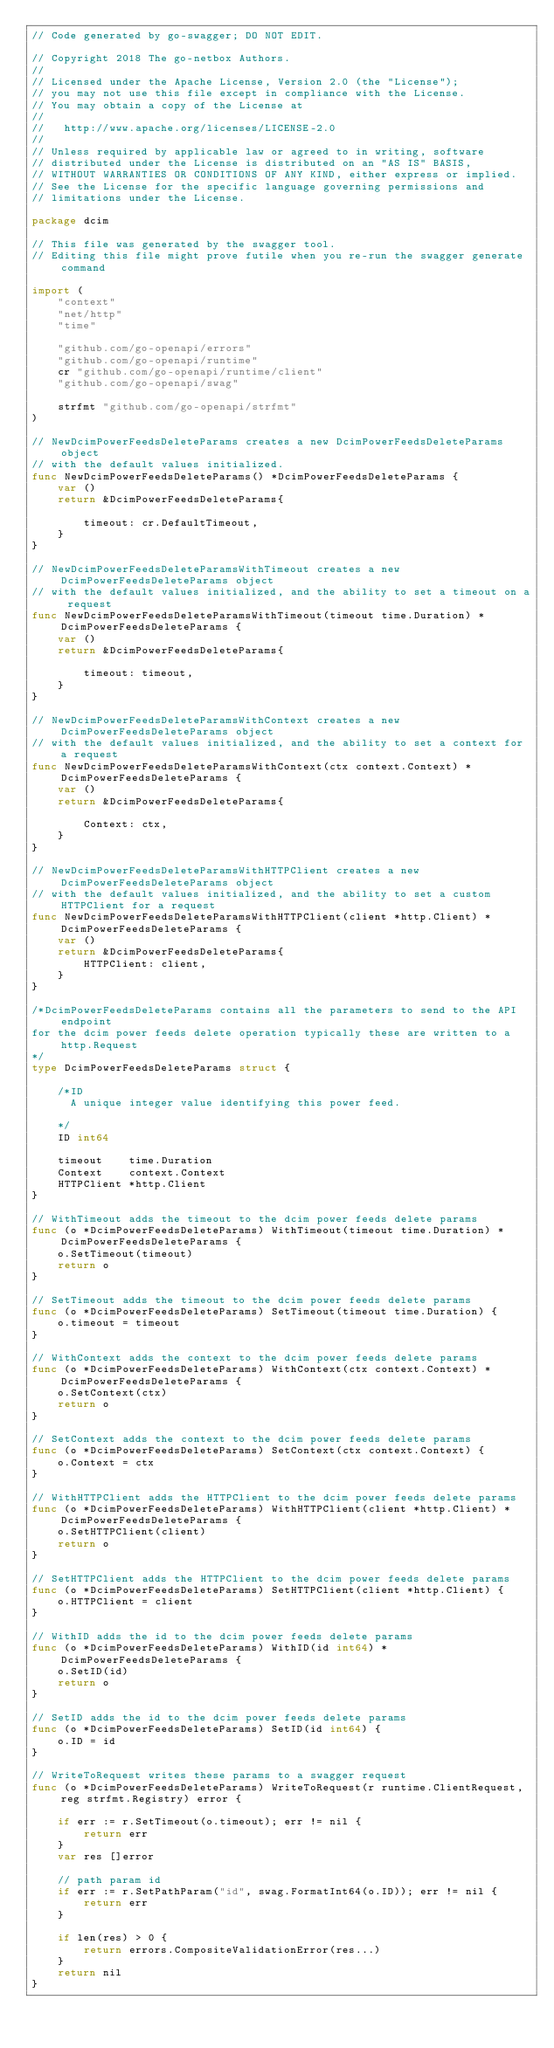Convert code to text. <code><loc_0><loc_0><loc_500><loc_500><_Go_>// Code generated by go-swagger; DO NOT EDIT.

// Copyright 2018 The go-netbox Authors.
//
// Licensed under the Apache License, Version 2.0 (the "License");
// you may not use this file except in compliance with the License.
// You may obtain a copy of the License at
//
//   http://www.apache.org/licenses/LICENSE-2.0
//
// Unless required by applicable law or agreed to in writing, software
// distributed under the License is distributed on an "AS IS" BASIS,
// WITHOUT WARRANTIES OR CONDITIONS OF ANY KIND, either express or implied.
// See the License for the specific language governing permissions and
// limitations under the License.

package dcim

// This file was generated by the swagger tool.
// Editing this file might prove futile when you re-run the swagger generate command

import (
	"context"
	"net/http"
	"time"

	"github.com/go-openapi/errors"
	"github.com/go-openapi/runtime"
	cr "github.com/go-openapi/runtime/client"
	"github.com/go-openapi/swag"

	strfmt "github.com/go-openapi/strfmt"
)

// NewDcimPowerFeedsDeleteParams creates a new DcimPowerFeedsDeleteParams object
// with the default values initialized.
func NewDcimPowerFeedsDeleteParams() *DcimPowerFeedsDeleteParams {
	var ()
	return &DcimPowerFeedsDeleteParams{

		timeout: cr.DefaultTimeout,
	}
}

// NewDcimPowerFeedsDeleteParamsWithTimeout creates a new DcimPowerFeedsDeleteParams object
// with the default values initialized, and the ability to set a timeout on a request
func NewDcimPowerFeedsDeleteParamsWithTimeout(timeout time.Duration) *DcimPowerFeedsDeleteParams {
	var ()
	return &DcimPowerFeedsDeleteParams{

		timeout: timeout,
	}
}

// NewDcimPowerFeedsDeleteParamsWithContext creates a new DcimPowerFeedsDeleteParams object
// with the default values initialized, and the ability to set a context for a request
func NewDcimPowerFeedsDeleteParamsWithContext(ctx context.Context) *DcimPowerFeedsDeleteParams {
	var ()
	return &DcimPowerFeedsDeleteParams{

		Context: ctx,
	}
}

// NewDcimPowerFeedsDeleteParamsWithHTTPClient creates a new DcimPowerFeedsDeleteParams object
// with the default values initialized, and the ability to set a custom HTTPClient for a request
func NewDcimPowerFeedsDeleteParamsWithHTTPClient(client *http.Client) *DcimPowerFeedsDeleteParams {
	var ()
	return &DcimPowerFeedsDeleteParams{
		HTTPClient: client,
	}
}

/*DcimPowerFeedsDeleteParams contains all the parameters to send to the API endpoint
for the dcim power feeds delete operation typically these are written to a http.Request
*/
type DcimPowerFeedsDeleteParams struct {

	/*ID
	  A unique integer value identifying this power feed.

	*/
	ID int64

	timeout    time.Duration
	Context    context.Context
	HTTPClient *http.Client
}

// WithTimeout adds the timeout to the dcim power feeds delete params
func (o *DcimPowerFeedsDeleteParams) WithTimeout(timeout time.Duration) *DcimPowerFeedsDeleteParams {
	o.SetTimeout(timeout)
	return o
}

// SetTimeout adds the timeout to the dcim power feeds delete params
func (o *DcimPowerFeedsDeleteParams) SetTimeout(timeout time.Duration) {
	o.timeout = timeout
}

// WithContext adds the context to the dcim power feeds delete params
func (o *DcimPowerFeedsDeleteParams) WithContext(ctx context.Context) *DcimPowerFeedsDeleteParams {
	o.SetContext(ctx)
	return o
}

// SetContext adds the context to the dcim power feeds delete params
func (o *DcimPowerFeedsDeleteParams) SetContext(ctx context.Context) {
	o.Context = ctx
}

// WithHTTPClient adds the HTTPClient to the dcim power feeds delete params
func (o *DcimPowerFeedsDeleteParams) WithHTTPClient(client *http.Client) *DcimPowerFeedsDeleteParams {
	o.SetHTTPClient(client)
	return o
}

// SetHTTPClient adds the HTTPClient to the dcim power feeds delete params
func (o *DcimPowerFeedsDeleteParams) SetHTTPClient(client *http.Client) {
	o.HTTPClient = client
}

// WithID adds the id to the dcim power feeds delete params
func (o *DcimPowerFeedsDeleteParams) WithID(id int64) *DcimPowerFeedsDeleteParams {
	o.SetID(id)
	return o
}

// SetID adds the id to the dcim power feeds delete params
func (o *DcimPowerFeedsDeleteParams) SetID(id int64) {
	o.ID = id
}

// WriteToRequest writes these params to a swagger request
func (o *DcimPowerFeedsDeleteParams) WriteToRequest(r runtime.ClientRequest, reg strfmt.Registry) error {

	if err := r.SetTimeout(o.timeout); err != nil {
		return err
	}
	var res []error

	// path param id
	if err := r.SetPathParam("id", swag.FormatInt64(o.ID)); err != nil {
		return err
	}

	if len(res) > 0 {
		return errors.CompositeValidationError(res...)
	}
	return nil
}
</code> 